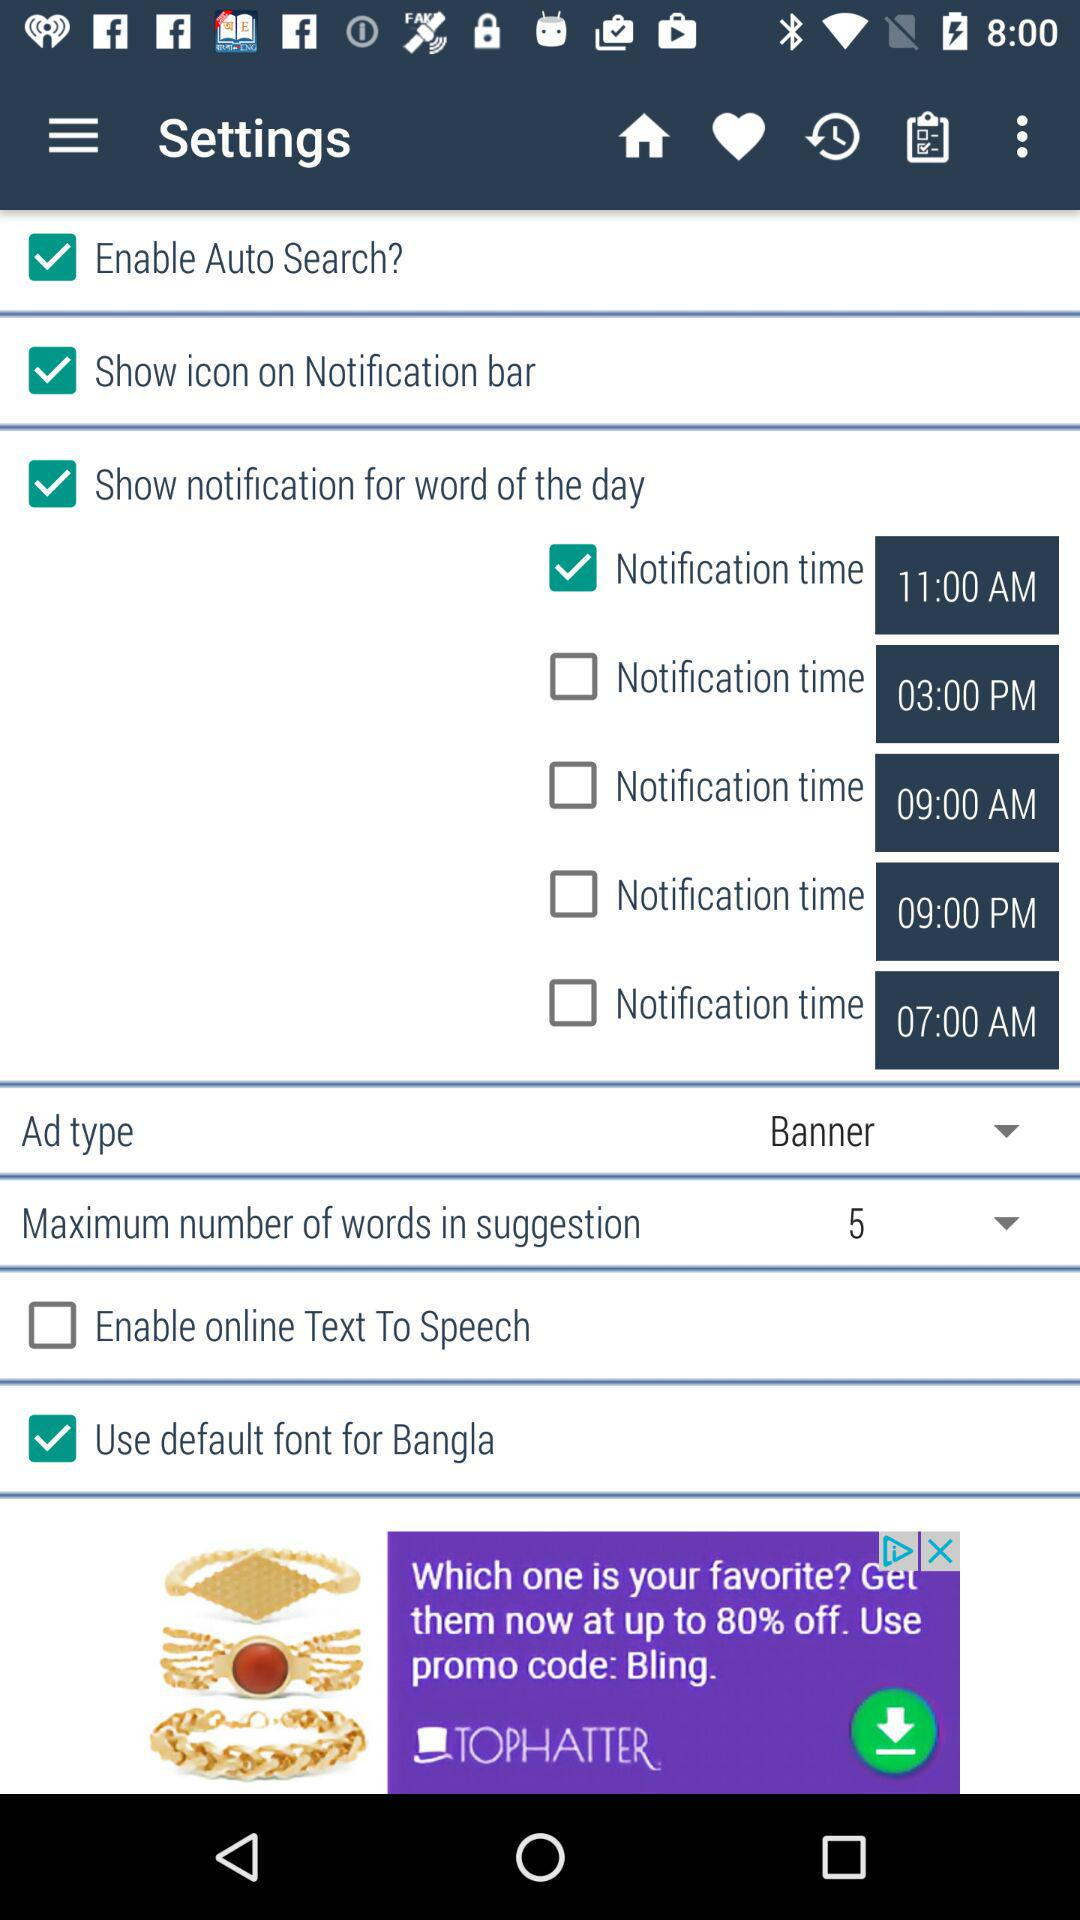How many notification times are there?
Answer the question using a single word or phrase. 5 